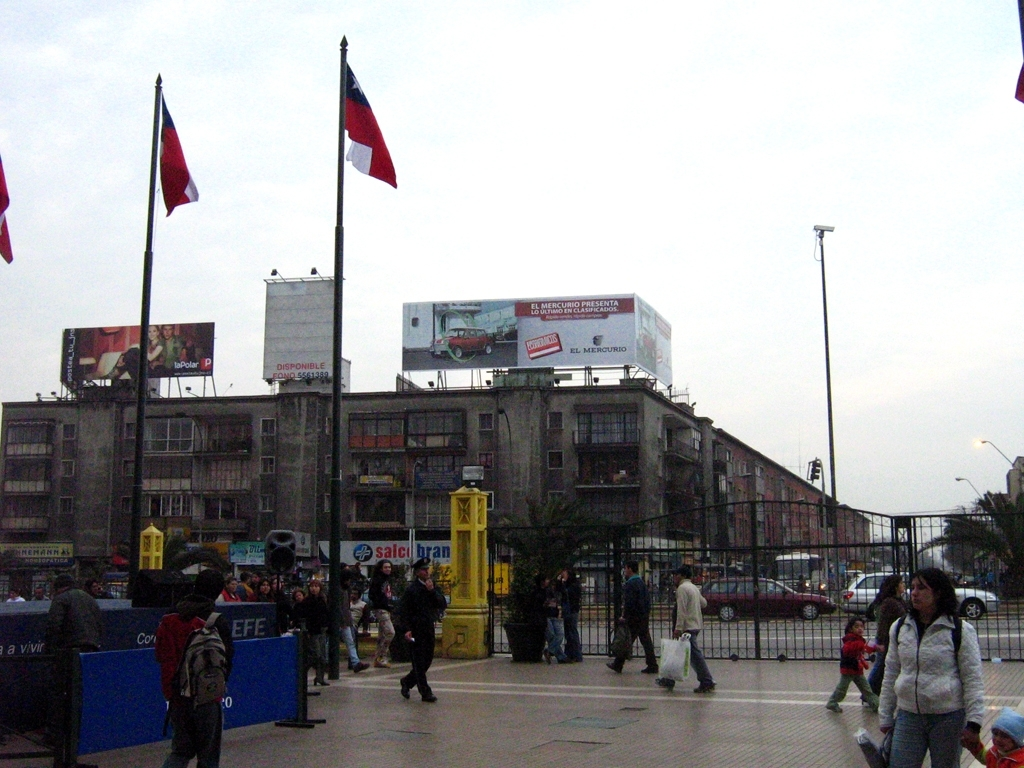What is the clarity of this photo?
A. acceptable
B. sharp
C. blurry
D. clear
Answer with the option's letter from the given choices directly. The clarity of the photo is generally acceptable but not high quality. It has a somewhat grainy and washed-out look, likely due to overcast weather, which generally reduces the sharpness and vibrancy seen in photographs taken in brighter lighting. 